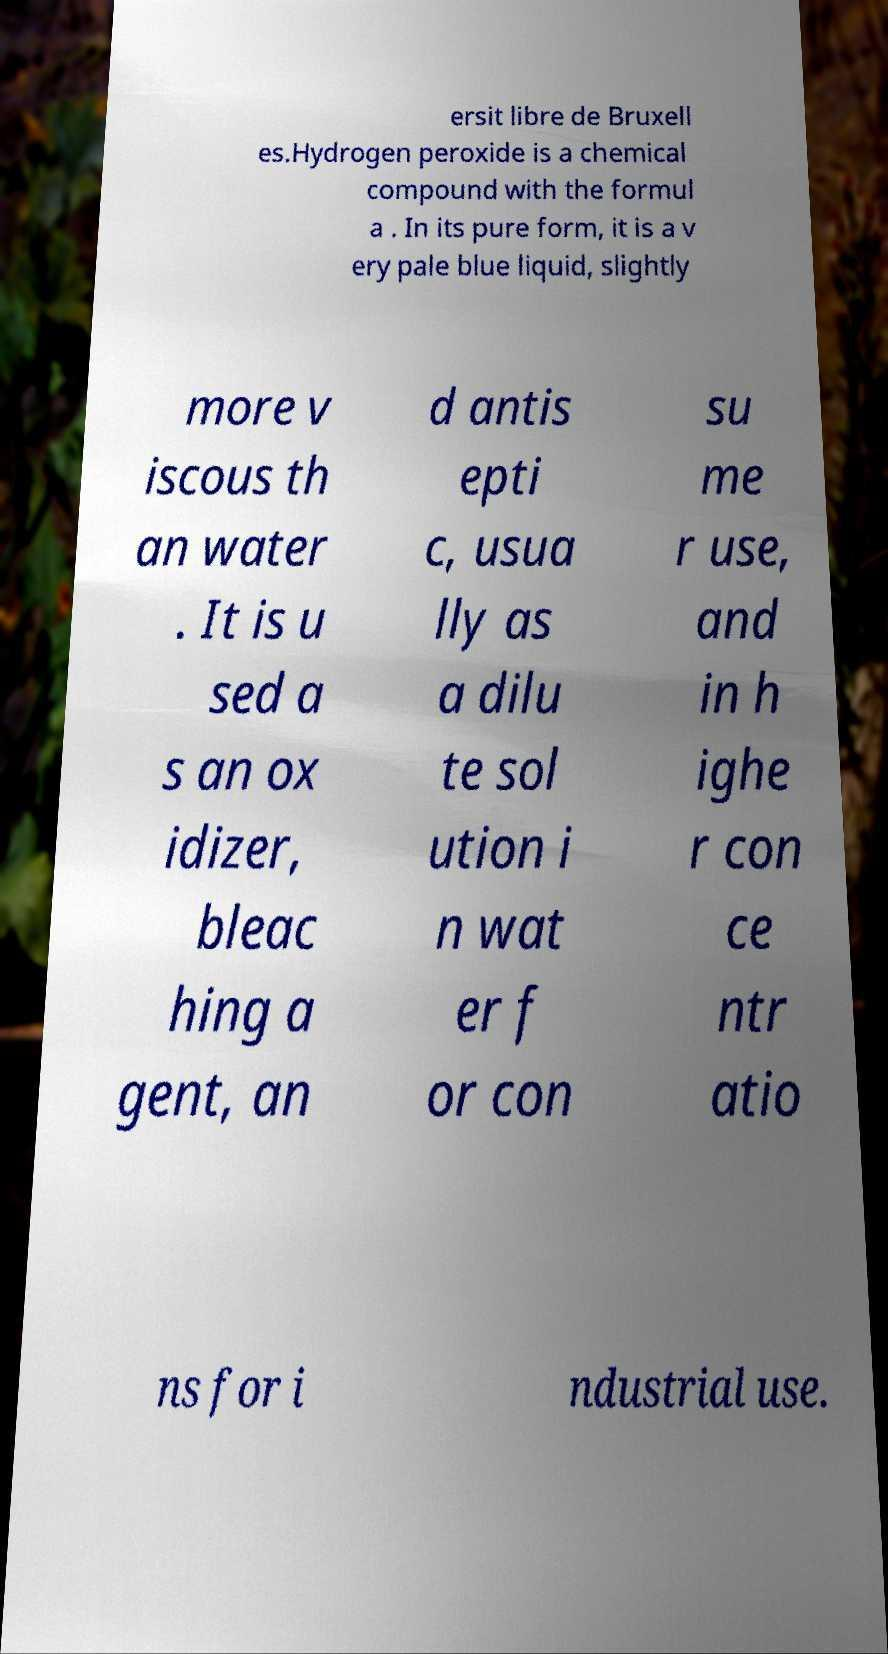Please identify and transcribe the text found in this image. ersit libre de Bruxell es.Hydrogen peroxide is a chemical compound with the formul a . In its pure form, it is a v ery pale blue liquid, slightly more v iscous th an water . It is u sed a s an ox idizer, bleac hing a gent, an d antis epti c, usua lly as a dilu te sol ution i n wat er f or con su me r use, and in h ighe r con ce ntr atio ns for i ndustrial use. 